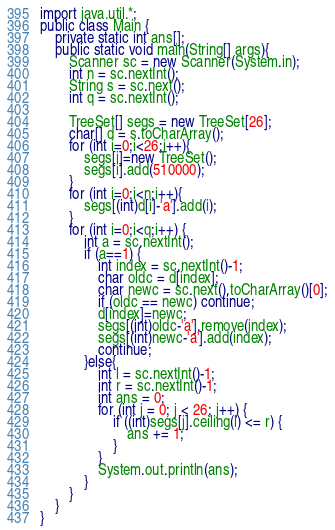Convert code to text. <code><loc_0><loc_0><loc_500><loc_500><_Java_>import java.util.*;
public class Main {
	private static int ans[];
	public static void main(String[] args){
    	Scanner sc = new Scanner(System.in);
    	int n = sc.nextInt();
    	String s = sc.next();
    	int q = sc.nextInt();

    	TreeSet[] segs = new TreeSet[26];
    	char[] d = s.toCharArray();
    	for (int i=0;i<26;i++){
    		segs[i]=new TreeSet();
    		segs[i].add(510000);
    	}
    	for (int i=0;i<n;i++){
    		segs[(int)d[i]-'a'].add(i);
    	}
    	for (int i=0;i<q;i++) {
    		int a = sc.nextInt();
    		if (a==1) {
    			int index = sc.nextInt()-1;
    			char oldc = d[index];
    			char newc = sc.next().toCharArray()[0];
    			if (oldc == newc) continue;
    			d[index]=newc;
    			segs[(int)oldc-'a'].remove(index);
    			segs[(int)newc-'a'].add(index);
    			continue;
    		}else{
	            int l = sc.nextInt()-1;
	            int r = sc.nextInt()-1;
	            int ans = 0;
	            for (int j = 0; j < 26; j++) {
	                if ((int)segs[j].ceiling(l) <= r) {
	                    ans += 1;
	                }
	            }
	            System.out.println(ans);
    		}
    	}
    }
} 

</code> 